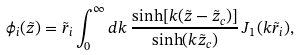Convert formula to latex. <formula><loc_0><loc_0><loc_500><loc_500>\phi _ { i } ( \tilde { z } ) = \tilde { r } _ { i } \int _ { 0 } ^ { \infty } d k \, \frac { \sinh [ k ( \tilde { z } - \tilde { z } _ { c } ) ] } { \sinh ( k \tilde { z } _ { c } ) } \, J _ { 1 } ( k \tilde { r } _ { i } ) ,</formula> 